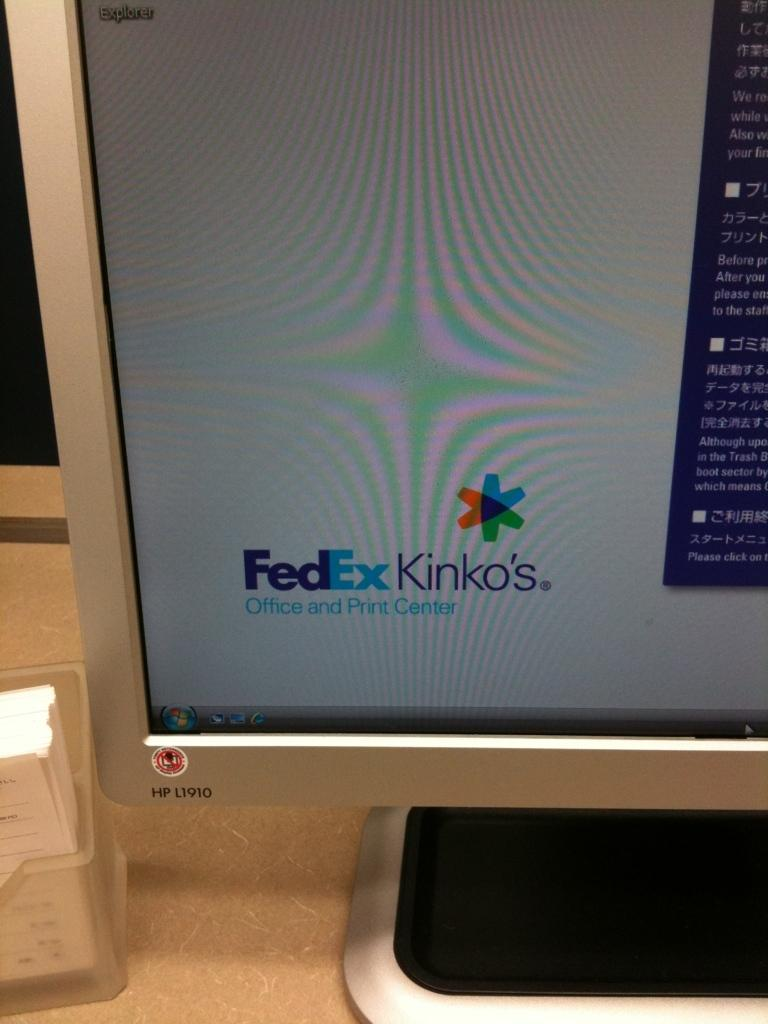<image>
Describe the image concisely. A computer monitor on the FedEx and Kinko's website. 